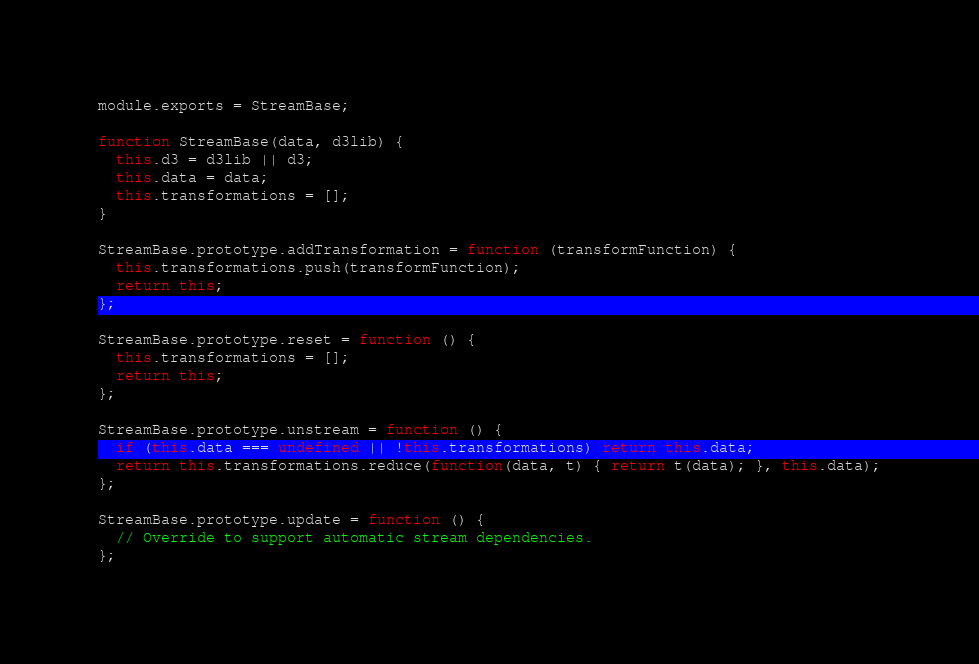<code> <loc_0><loc_0><loc_500><loc_500><_JavaScript_>module.exports = StreamBase;

function StreamBase(data, d3lib) {
  this.d3 = d3lib || d3;
  this.data = data;
  this.transformations = [];
}

StreamBase.prototype.addTransformation = function (transformFunction) {
  this.transformations.push(transformFunction);
  return this;
};

StreamBase.prototype.reset = function () {
  this.transformations = [];
  return this;
};

StreamBase.prototype.unstream = function () {
  if (this.data === undefined || !this.transformations) return this.data;
  return this.transformations.reduce(function(data, t) { return t(data); }, this.data);
};

StreamBase.prototype.update = function () {
  // Override to support automatic stream dependencies.
};
</code> 